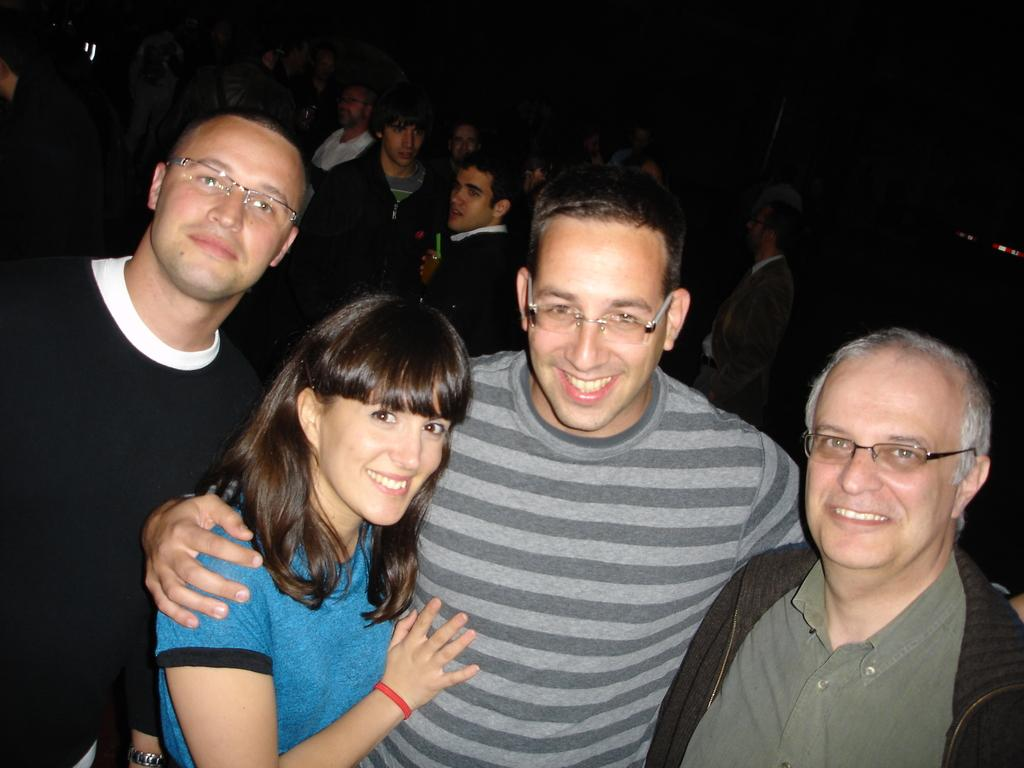How many men with glasses can be seen in the image? There are three men with glasses in the image. What is the woman in the image doing? The woman is standing and smiling in the image. Can you describe the background of the image? There are people in the background of the image. At what time of day was the image taken? The image was taken during night time. What type of stone is being distributed by the cow in the image? There is no cow or stone present in the image. 